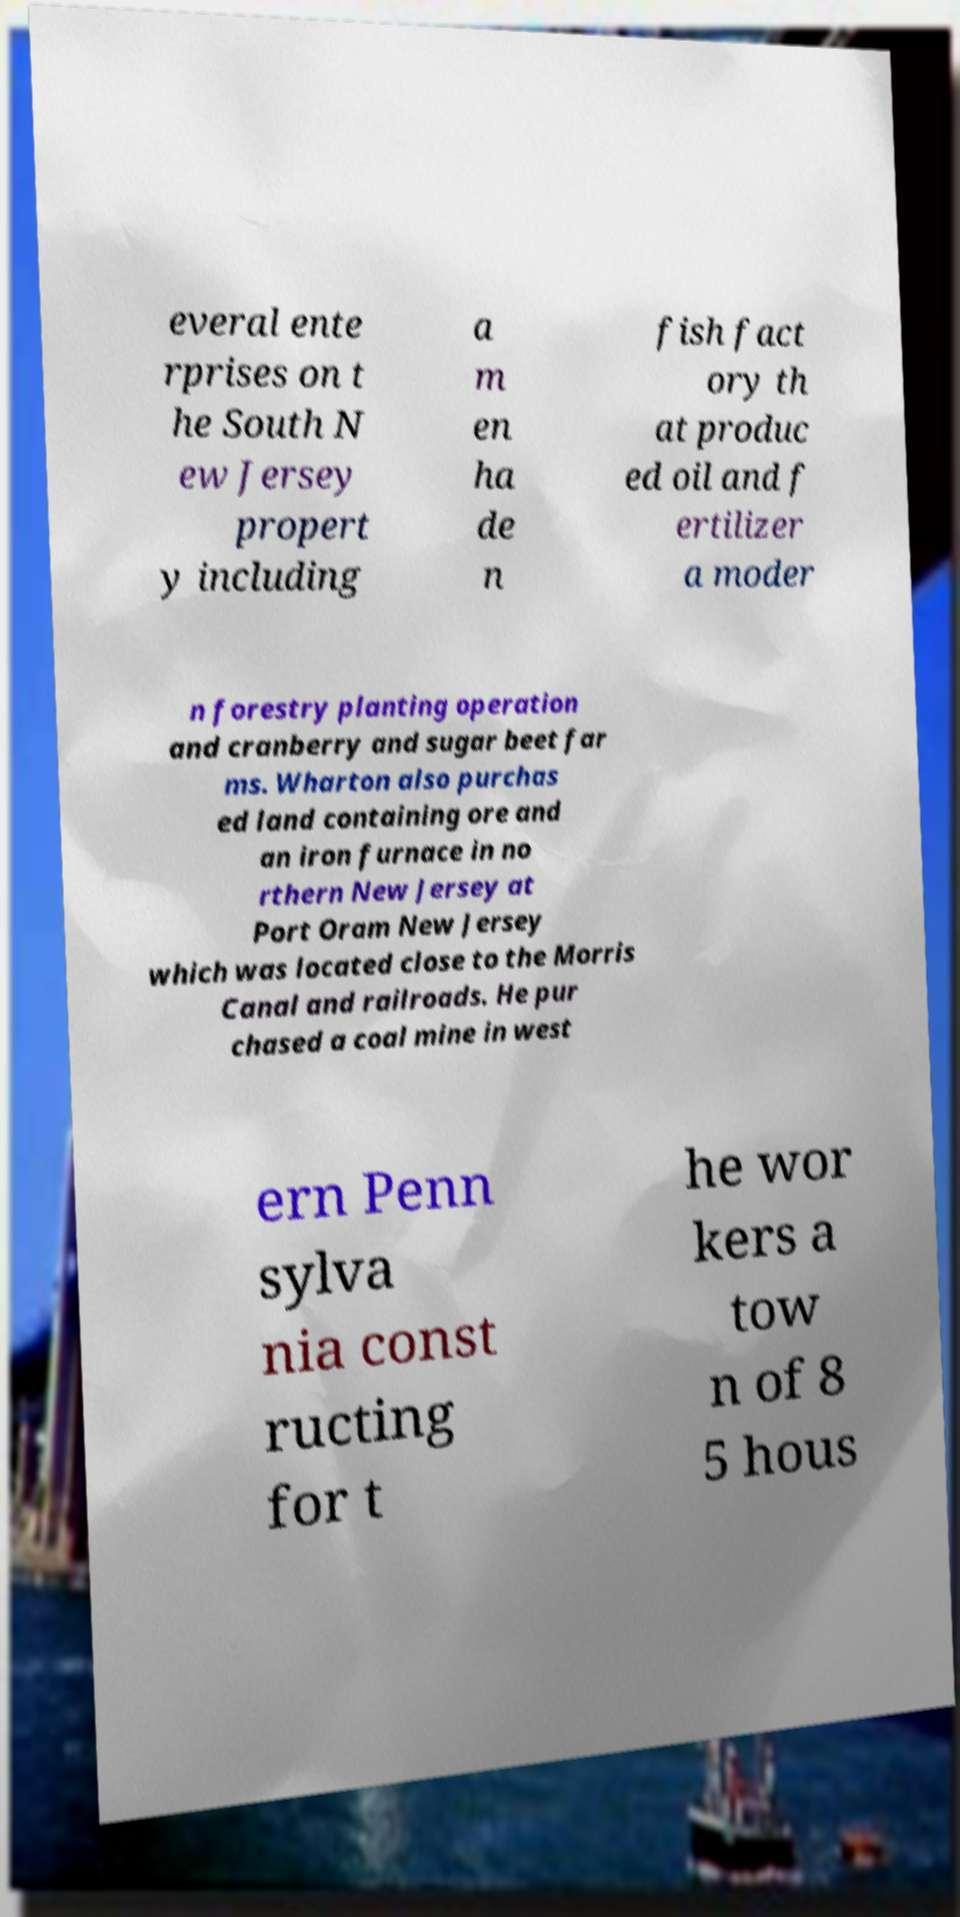For documentation purposes, I need the text within this image transcribed. Could you provide that? everal ente rprises on t he South N ew Jersey propert y including a m en ha de n fish fact ory th at produc ed oil and f ertilizer a moder n forestry planting operation and cranberry and sugar beet far ms. Wharton also purchas ed land containing ore and an iron furnace in no rthern New Jersey at Port Oram New Jersey which was located close to the Morris Canal and railroads. He pur chased a coal mine in west ern Penn sylva nia const ructing for t he wor kers a tow n of 8 5 hous 